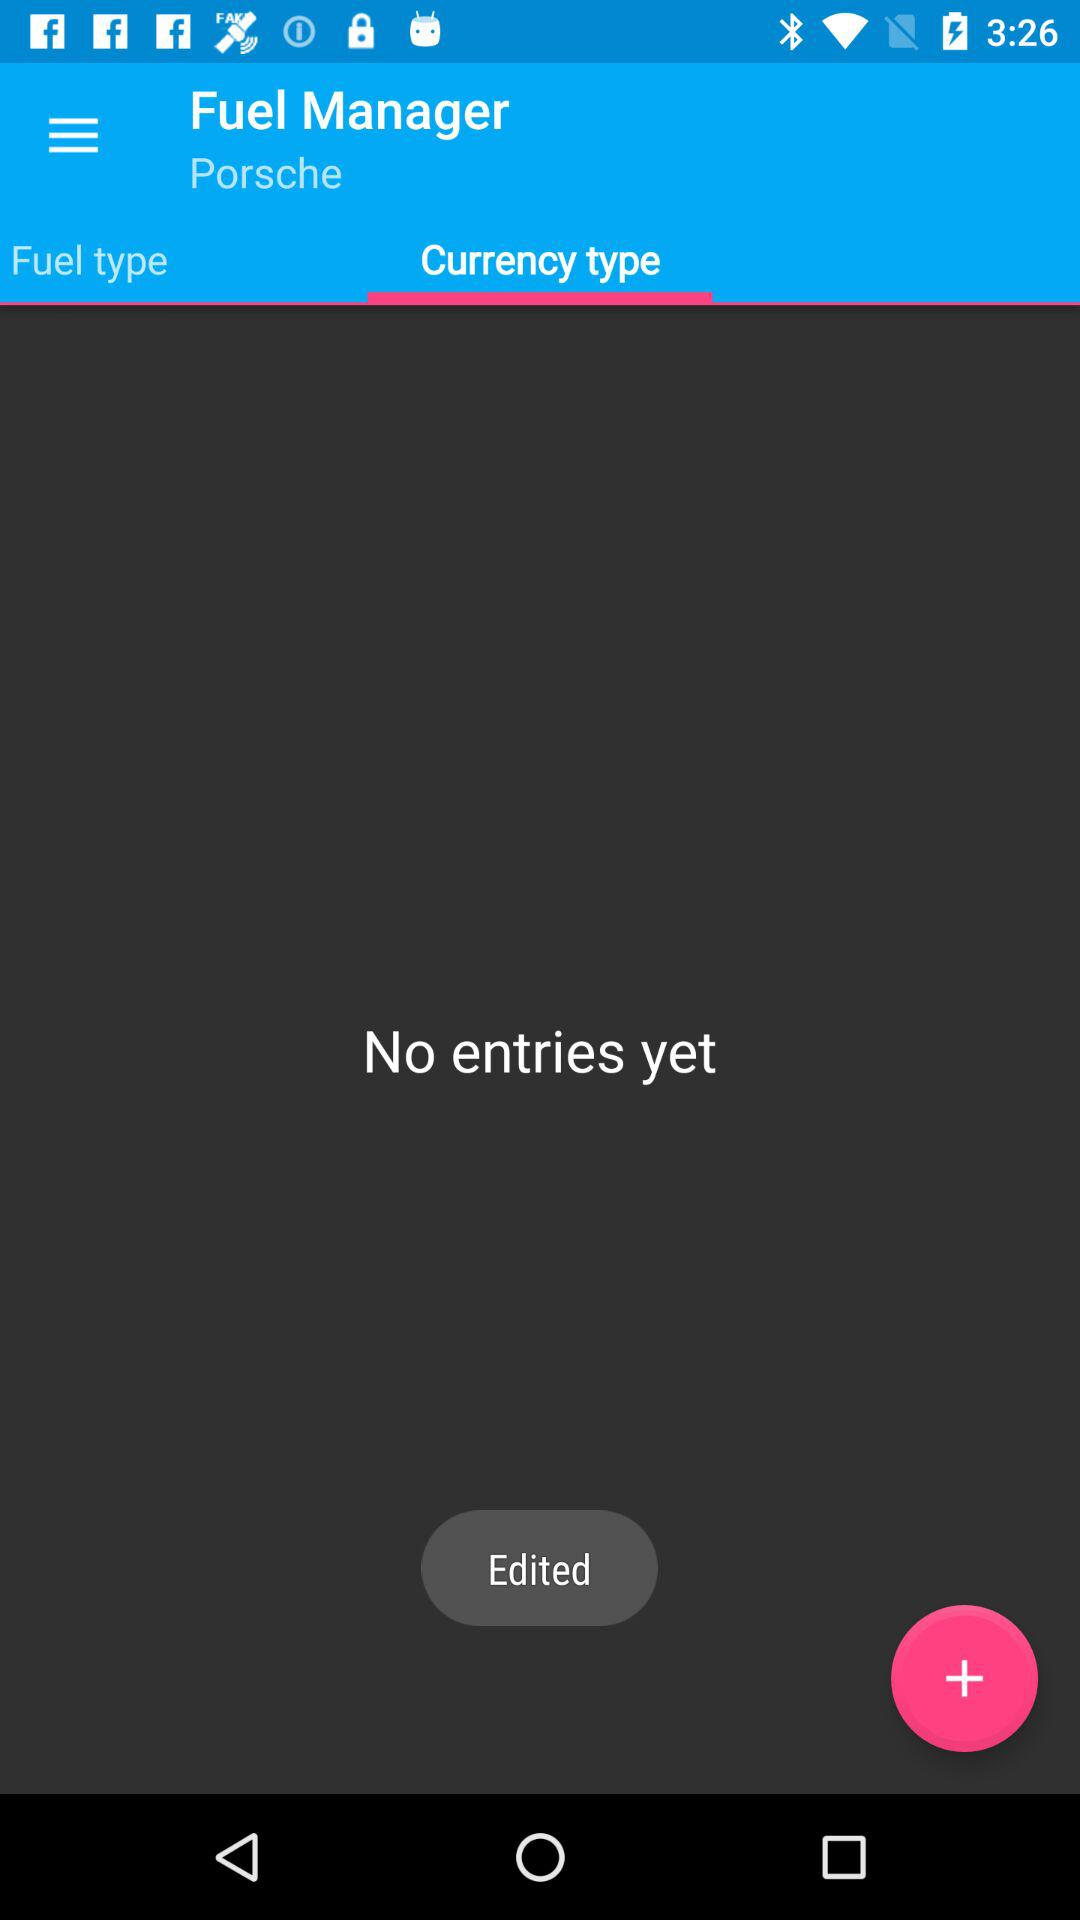Which tab has been selected? The selected tab is "Currency type". 